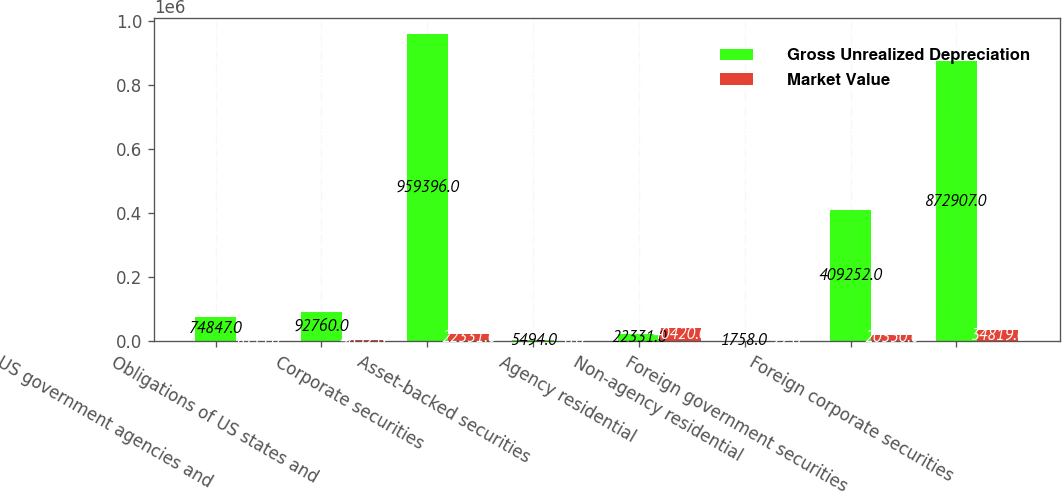Convert chart. <chart><loc_0><loc_0><loc_500><loc_500><stacked_bar_chart><ecel><fcel>US government agencies and<fcel>Obligations of US states and<fcel>Corporate securities<fcel>Asset-backed securities<fcel>Agency residential<fcel>Non-agency residential<fcel>Foreign government securities<fcel>Foreign corporate securities<nl><fcel>Gross Unrealized Depreciation<fcel>74847<fcel>92760<fcel>959396<fcel>5494<fcel>22331<fcel>1758<fcel>409252<fcel>872907<nl><fcel>Market Value<fcel>1033<fcel>4852<fcel>22331<fcel>6<fcel>40420<fcel>22<fcel>20350<fcel>34819<nl></chart> 